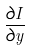Convert formula to latex. <formula><loc_0><loc_0><loc_500><loc_500>\frac { \partial I } { \partial y }</formula> 